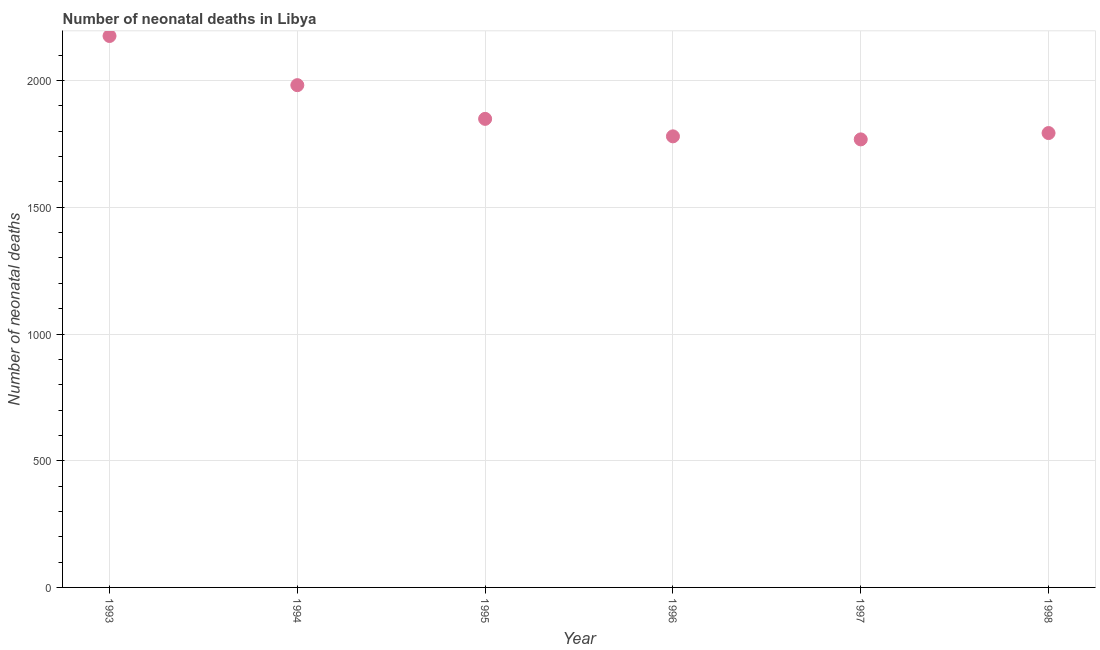What is the number of neonatal deaths in 1995?
Give a very brief answer. 1849. Across all years, what is the maximum number of neonatal deaths?
Your response must be concise. 2176. Across all years, what is the minimum number of neonatal deaths?
Offer a very short reply. 1768. In which year was the number of neonatal deaths maximum?
Make the answer very short. 1993. In which year was the number of neonatal deaths minimum?
Offer a terse response. 1997. What is the sum of the number of neonatal deaths?
Make the answer very short. 1.13e+04. What is the difference between the number of neonatal deaths in 1993 and 1998?
Keep it short and to the point. 383. What is the average number of neonatal deaths per year?
Give a very brief answer. 1891.33. What is the median number of neonatal deaths?
Ensure brevity in your answer.  1821. Do a majority of the years between 1994 and 1997 (inclusive) have number of neonatal deaths greater than 800 ?
Ensure brevity in your answer.  Yes. What is the ratio of the number of neonatal deaths in 1994 to that in 1997?
Give a very brief answer. 1.12. Is the difference between the number of neonatal deaths in 1994 and 1995 greater than the difference between any two years?
Offer a very short reply. No. What is the difference between the highest and the second highest number of neonatal deaths?
Keep it short and to the point. 194. Is the sum of the number of neonatal deaths in 1996 and 1997 greater than the maximum number of neonatal deaths across all years?
Ensure brevity in your answer.  Yes. What is the difference between the highest and the lowest number of neonatal deaths?
Make the answer very short. 408. Does the number of neonatal deaths monotonically increase over the years?
Give a very brief answer. No. What is the difference between two consecutive major ticks on the Y-axis?
Your answer should be very brief. 500. Are the values on the major ticks of Y-axis written in scientific E-notation?
Make the answer very short. No. Does the graph contain any zero values?
Keep it short and to the point. No. What is the title of the graph?
Your answer should be compact. Number of neonatal deaths in Libya. What is the label or title of the X-axis?
Your answer should be very brief. Year. What is the label or title of the Y-axis?
Offer a terse response. Number of neonatal deaths. What is the Number of neonatal deaths in 1993?
Your answer should be very brief. 2176. What is the Number of neonatal deaths in 1994?
Offer a very short reply. 1982. What is the Number of neonatal deaths in 1995?
Give a very brief answer. 1849. What is the Number of neonatal deaths in 1996?
Provide a short and direct response. 1780. What is the Number of neonatal deaths in 1997?
Your answer should be very brief. 1768. What is the Number of neonatal deaths in 1998?
Make the answer very short. 1793. What is the difference between the Number of neonatal deaths in 1993 and 1994?
Ensure brevity in your answer.  194. What is the difference between the Number of neonatal deaths in 1993 and 1995?
Offer a terse response. 327. What is the difference between the Number of neonatal deaths in 1993 and 1996?
Give a very brief answer. 396. What is the difference between the Number of neonatal deaths in 1993 and 1997?
Offer a very short reply. 408. What is the difference between the Number of neonatal deaths in 1993 and 1998?
Your answer should be very brief. 383. What is the difference between the Number of neonatal deaths in 1994 and 1995?
Your answer should be compact. 133. What is the difference between the Number of neonatal deaths in 1994 and 1996?
Your answer should be very brief. 202. What is the difference between the Number of neonatal deaths in 1994 and 1997?
Offer a very short reply. 214. What is the difference between the Number of neonatal deaths in 1994 and 1998?
Your response must be concise. 189. What is the difference between the Number of neonatal deaths in 1995 and 1996?
Ensure brevity in your answer.  69. What is the difference between the Number of neonatal deaths in 1996 and 1997?
Provide a succinct answer. 12. What is the difference between the Number of neonatal deaths in 1997 and 1998?
Keep it short and to the point. -25. What is the ratio of the Number of neonatal deaths in 1993 to that in 1994?
Your answer should be very brief. 1.1. What is the ratio of the Number of neonatal deaths in 1993 to that in 1995?
Your response must be concise. 1.18. What is the ratio of the Number of neonatal deaths in 1993 to that in 1996?
Your answer should be compact. 1.22. What is the ratio of the Number of neonatal deaths in 1993 to that in 1997?
Your answer should be very brief. 1.23. What is the ratio of the Number of neonatal deaths in 1993 to that in 1998?
Your answer should be very brief. 1.21. What is the ratio of the Number of neonatal deaths in 1994 to that in 1995?
Provide a short and direct response. 1.07. What is the ratio of the Number of neonatal deaths in 1994 to that in 1996?
Give a very brief answer. 1.11. What is the ratio of the Number of neonatal deaths in 1994 to that in 1997?
Your answer should be compact. 1.12. What is the ratio of the Number of neonatal deaths in 1994 to that in 1998?
Provide a succinct answer. 1.1. What is the ratio of the Number of neonatal deaths in 1995 to that in 1996?
Your answer should be compact. 1.04. What is the ratio of the Number of neonatal deaths in 1995 to that in 1997?
Your answer should be very brief. 1.05. What is the ratio of the Number of neonatal deaths in 1995 to that in 1998?
Give a very brief answer. 1.03. What is the ratio of the Number of neonatal deaths in 1996 to that in 1997?
Make the answer very short. 1.01. What is the ratio of the Number of neonatal deaths in 1996 to that in 1998?
Your response must be concise. 0.99. What is the ratio of the Number of neonatal deaths in 1997 to that in 1998?
Give a very brief answer. 0.99. 